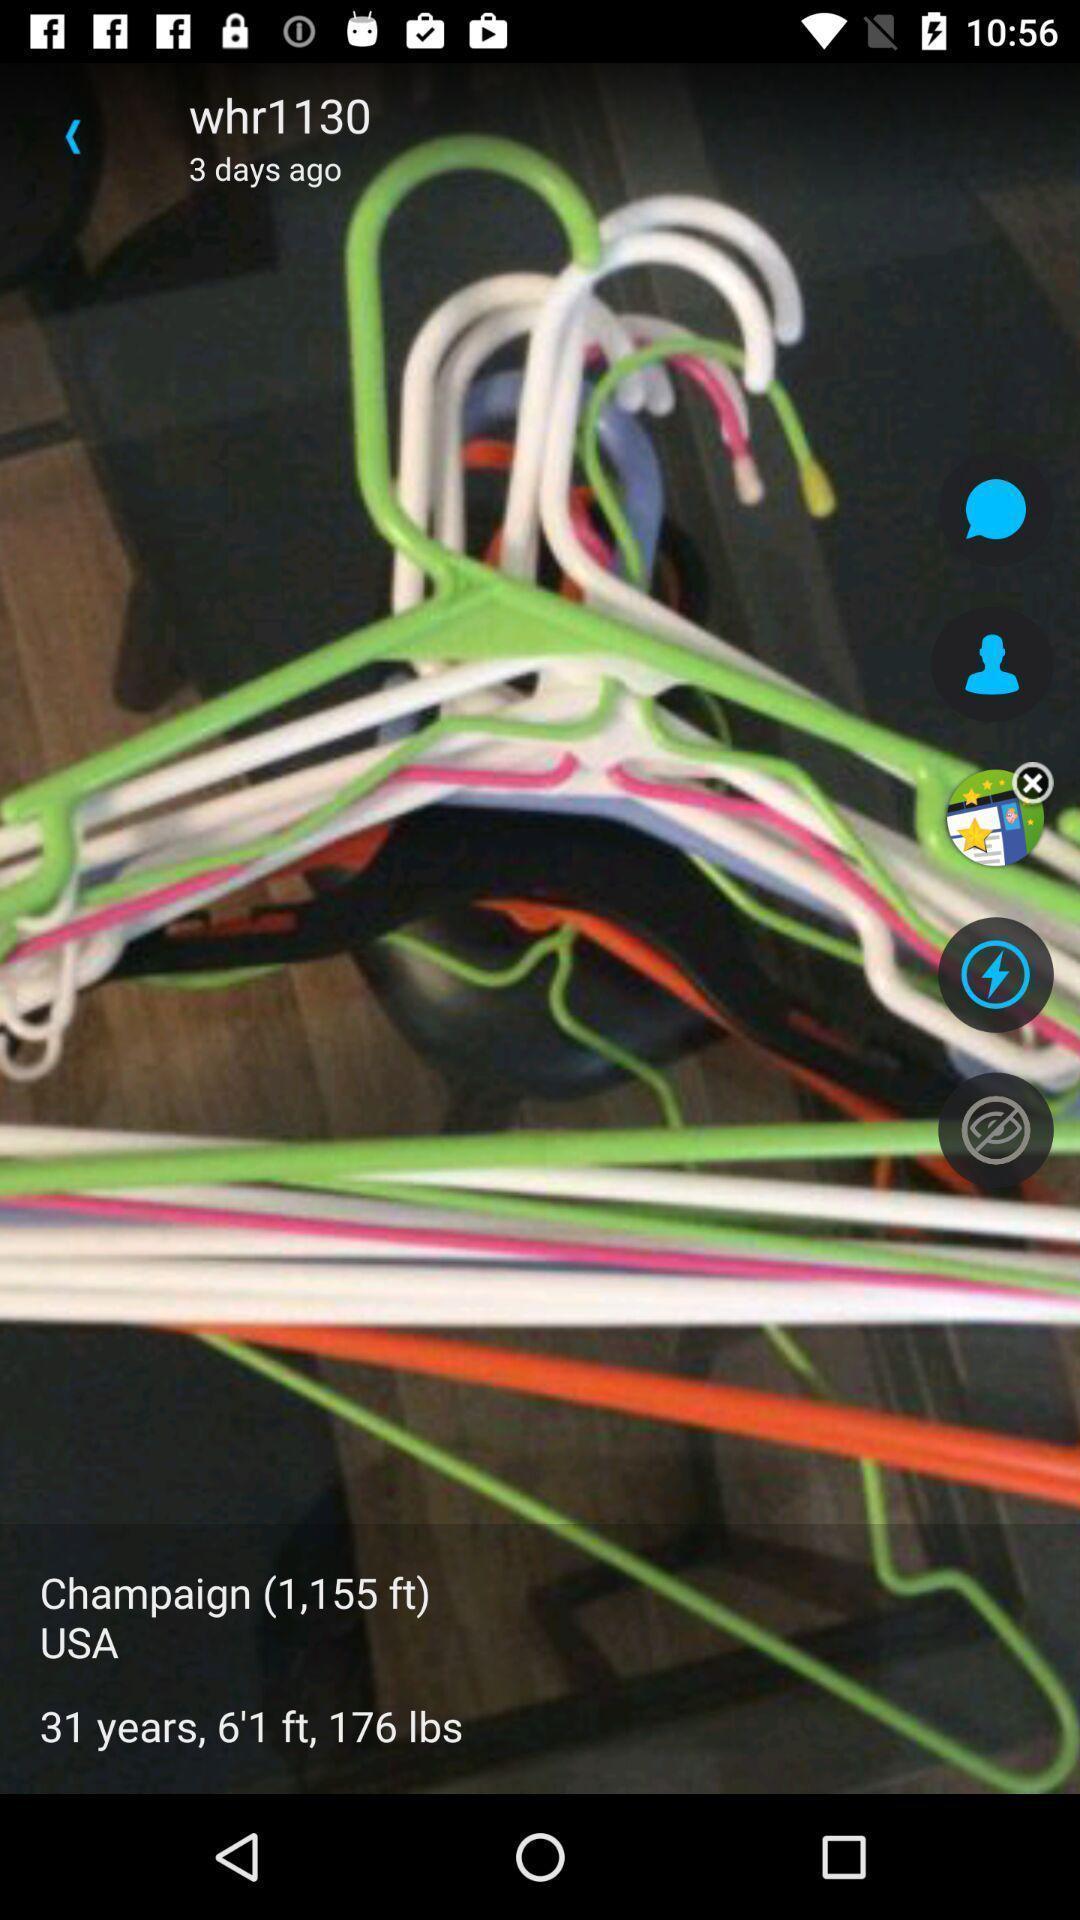What is the overall content of this screenshot? Page showing image in app. 